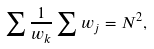Convert formula to latex. <formula><loc_0><loc_0><loc_500><loc_500>\sum { \frac { 1 } { w _ { k } } } \sum { w _ { j } } = N ^ { 2 } ,</formula> 